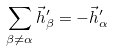Convert formula to latex. <formula><loc_0><loc_0><loc_500><loc_500>\sum _ { \beta \neq \alpha } \vec { h } ^ { \prime } _ { \beta } = - \vec { h } ^ { \prime } _ { \alpha }</formula> 